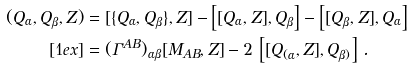<formula> <loc_0><loc_0><loc_500><loc_500>( Q _ { \alpha } , Q _ { \beta } , Z ) & = [ \{ Q _ { \alpha } , Q _ { \beta } \} , Z ] - \left [ [ Q _ { \alpha } , Z ] , Q _ { \beta } \right ] - \left [ [ Q _ { \beta } , Z ] , Q _ { \alpha } \right ] \\ [ 1 e x ] & = ( \Gamma ^ { A B } ) _ { \alpha \beta } [ M _ { A B } , Z ] - 2 \, \left [ [ Q _ { ( \alpha } , Z ] , Q _ { \beta ) } \right ] \, .</formula> 